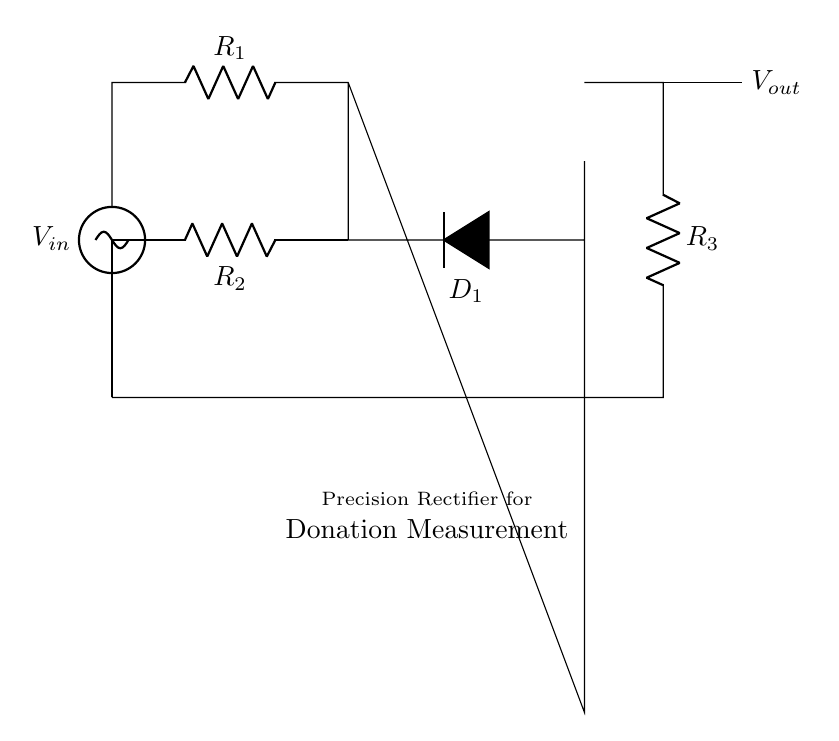What type of circuit is this? This is a precision rectifier circuit, which is designed to convert an AC input signal into a precise DC output signal while maintaining accuracy in measurement.
Answer: Precision rectifier What does the op amp do in this circuit? The op amp in this circuit amplifies the input voltage and ensures that the diode conducts during the positive half-cycle, allowing for precise rectification of the input signal.
Answer: Amplifies voltage Which component ensures current flows in one direction? The diode in the circuit, labeled as D1, allows current to flow in one direction and blocks reverse current, which is essential for rectification.
Answer: Diode What is connected to the non-inverting input of the op amp? The voltage source, V_in, is connected to the non-inverting input of the op amp, which is crucial for the operation of the precision rectifier.
Answer: Voltage source How many resistors are present in this circuit? There are three resistors in the circuit, labeled as R1, R2, and R3, each serving a specific purpose in controlling current and voltage levels within the precision rectifier.
Answer: Three What is the role of resistor R2? Resistor R2 is part of the feedback loop for the op amp, which helps in stabilizing the gain and controlling the output voltage in accordance with the input signal.
Answer: Feedback control What output voltage can be expected when the input voltage is zero? When the input voltage, V_in, is zero, the output voltage, V_out, will also be zero, as the circuit will not produce an output without an input signal.
Answer: Zero 